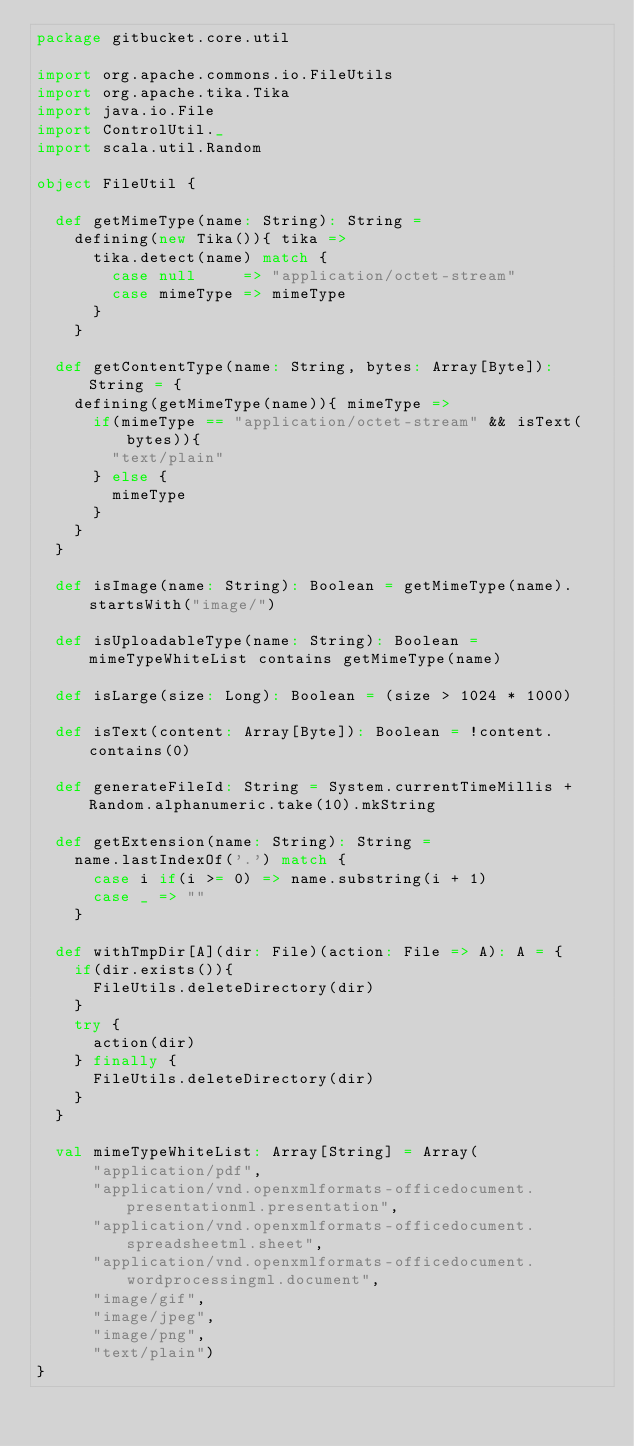<code> <loc_0><loc_0><loc_500><loc_500><_Scala_>package gitbucket.core.util

import org.apache.commons.io.FileUtils
import org.apache.tika.Tika
import java.io.File
import ControlUtil._
import scala.util.Random

object FileUtil {

  def getMimeType(name: String): String =
    defining(new Tika()){ tika =>
      tika.detect(name) match {
        case null     => "application/octet-stream"
        case mimeType => mimeType
      }
    }

  def getContentType(name: String, bytes: Array[Byte]): String = {
    defining(getMimeType(name)){ mimeType =>
      if(mimeType == "application/octet-stream" && isText(bytes)){
        "text/plain"
      } else {
        mimeType
      }
    }
  }

  def isImage(name: String): Boolean = getMimeType(name).startsWith("image/")

  def isUploadableType(name: String): Boolean = mimeTypeWhiteList contains getMimeType(name)

  def isLarge(size: Long): Boolean = (size > 1024 * 1000)

  def isText(content: Array[Byte]): Boolean = !content.contains(0)

  def generateFileId: String = System.currentTimeMillis + Random.alphanumeric.take(10).mkString

  def getExtension(name: String): String =
    name.lastIndexOf('.') match {
      case i if(i >= 0) => name.substring(i + 1)
      case _ => ""
    }

  def withTmpDir[A](dir: File)(action: File => A): A = {
    if(dir.exists()){
      FileUtils.deleteDirectory(dir)
    }
    try {
      action(dir)
    } finally {
      FileUtils.deleteDirectory(dir)
    }
  }

  val mimeTypeWhiteList: Array[String] = Array(
      "application/pdf",
      "application/vnd.openxmlformats-officedocument.presentationml.presentation",
      "application/vnd.openxmlformats-officedocument.spreadsheetml.sheet",
      "application/vnd.openxmlformats-officedocument.wordprocessingml.document",
      "image/gif",
      "image/jpeg",
      "image/png",
      "text/plain")
}
</code> 